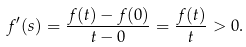Convert formula to latex. <formula><loc_0><loc_0><loc_500><loc_500>f ^ { \prime } ( s ) = \frac { f ( t ) - f ( 0 ) } { t - 0 } = \frac { f ( t ) } t > 0 .</formula> 